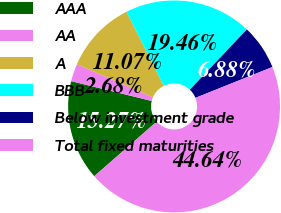Convert chart to OTSL. <chart><loc_0><loc_0><loc_500><loc_500><pie_chart><fcel>AAA<fcel>AA<fcel>A<fcel>BBB<fcel>Below investment grade<fcel>Total fixed maturities<nl><fcel>15.27%<fcel>2.68%<fcel>11.07%<fcel>19.46%<fcel>6.88%<fcel>44.64%<nl></chart> 